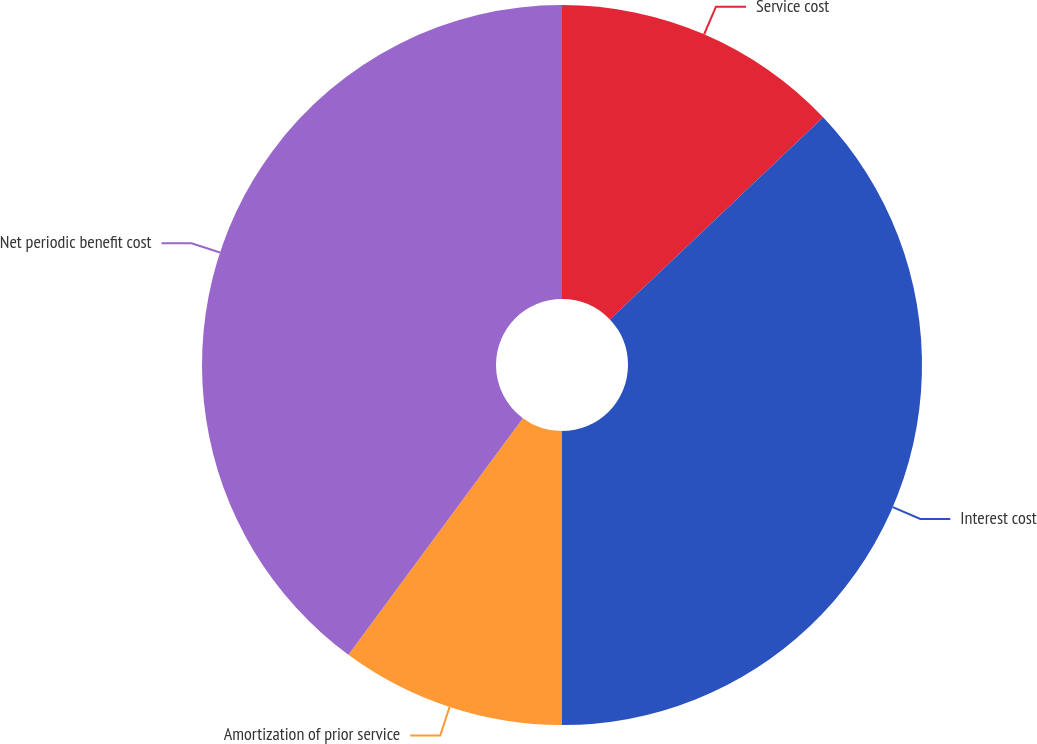Convert chart to OTSL. <chart><loc_0><loc_0><loc_500><loc_500><pie_chart><fcel>Service cost<fcel>Interest cost<fcel>Amortization of prior service<fcel>Net periodic benefit cost<nl><fcel>12.92%<fcel>37.08%<fcel>10.11%<fcel>39.89%<nl></chart> 